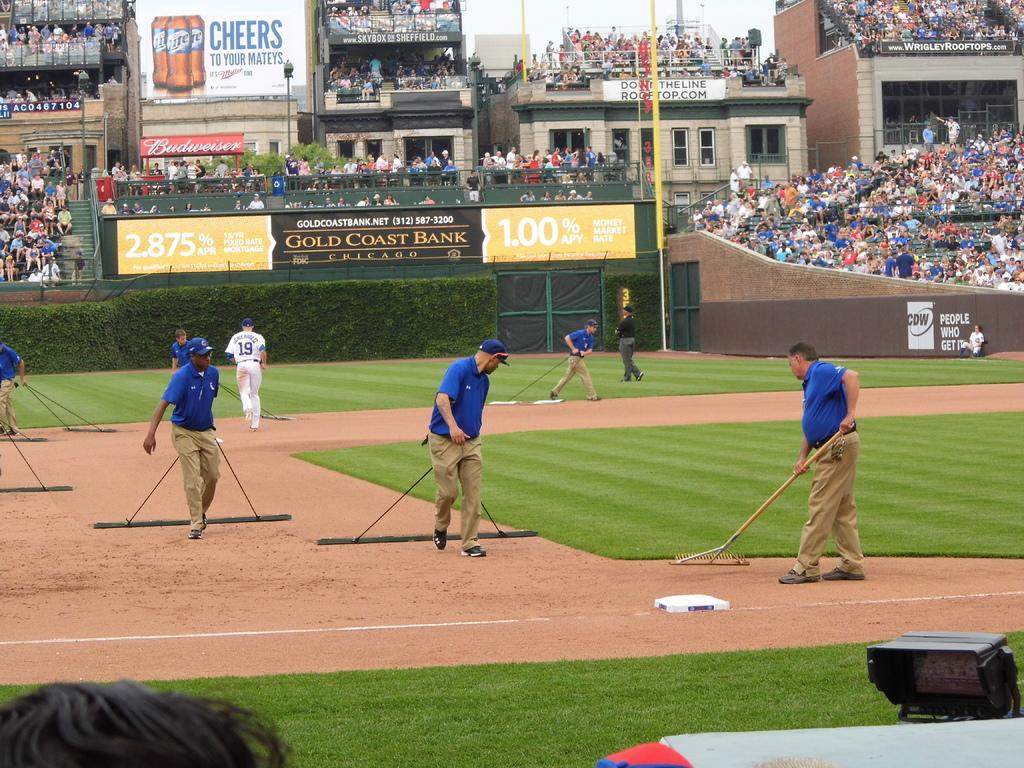<image>
Present a compact description of the photo's key features. A CDW ad is visible on the side of a ballpark fence. 